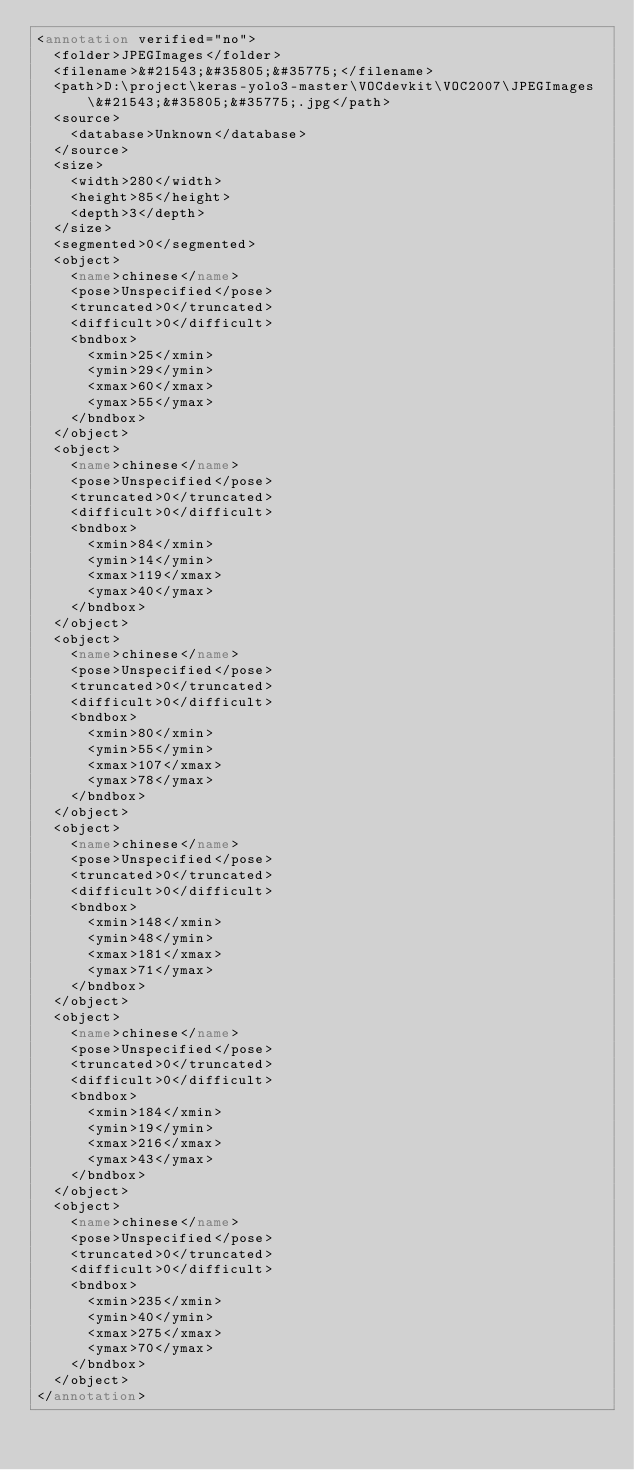Convert code to text. <code><loc_0><loc_0><loc_500><loc_500><_XML_><annotation verified="no">
  <folder>JPEGImages</folder>
  <filename>&#21543;&#35805;&#35775;</filename>
  <path>D:\project\keras-yolo3-master\VOCdevkit\VOC2007\JPEGImages\&#21543;&#35805;&#35775;.jpg</path>
  <source>
    <database>Unknown</database>
  </source>
  <size>
    <width>280</width>
    <height>85</height>
    <depth>3</depth>
  </size>
  <segmented>0</segmented>
  <object>
    <name>chinese</name>
    <pose>Unspecified</pose>
    <truncated>0</truncated>
    <difficult>0</difficult>
    <bndbox>
      <xmin>25</xmin>
      <ymin>29</ymin>
      <xmax>60</xmax>
      <ymax>55</ymax>
    </bndbox>
  </object>
  <object>
    <name>chinese</name>
    <pose>Unspecified</pose>
    <truncated>0</truncated>
    <difficult>0</difficult>
    <bndbox>
      <xmin>84</xmin>
      <ymin>14</ymin>
      <xmax>119</xmax>
      <ymax>40</ymax>
    </bndbox>
  </object>
  <object>
    <name>chinese</name>
    <pose>Unspecified</pose>
    <truncated>0</truncated>
    <difficult>0</difficult>
    <bndbox>
      <xmin>80</xmin>
      <ymin>55</ymin>
      <xmax>107</xmax>
      <ymax>78</ymax>
    </bndbox>
  </object>
  <object>
    <name>chinese</name>
    <pose>Unspecified</pose>
    <truncated>0</truncated>
    <difficult>0</difficult>
    <bndbox>
      <xmin>148</xmin>
      <ymin>48</ymin>
      <xmax>181</xmax>
      <ymax>71</ymax>
    </bndbox>
  </object>
  <object>
    <name>chinese</name>
    <pose>Unspecified</pose>
    <truncated>0</truncated>
    <difficult>0</difficult>
    <bndbox>
      <xmin>184</xmin>
      <ymin>19</ymin>
      <xmax>216</xmax>
      <ymax>43</ymax>
    </bndbox>
  </object>
  <object>
    <name>chinese</name>
    <pose>Unspecified</pose>
    <truncated>0</truncated>
    <difficult>0</difficult>
    <bndbox>
      <xmin>235</xmin>
      <ymin>40</ymin>
      <xmax>275</xmax>
      <ymax>70</ymax>
    </bndbox>
  </object>
</annotation>
</code> 